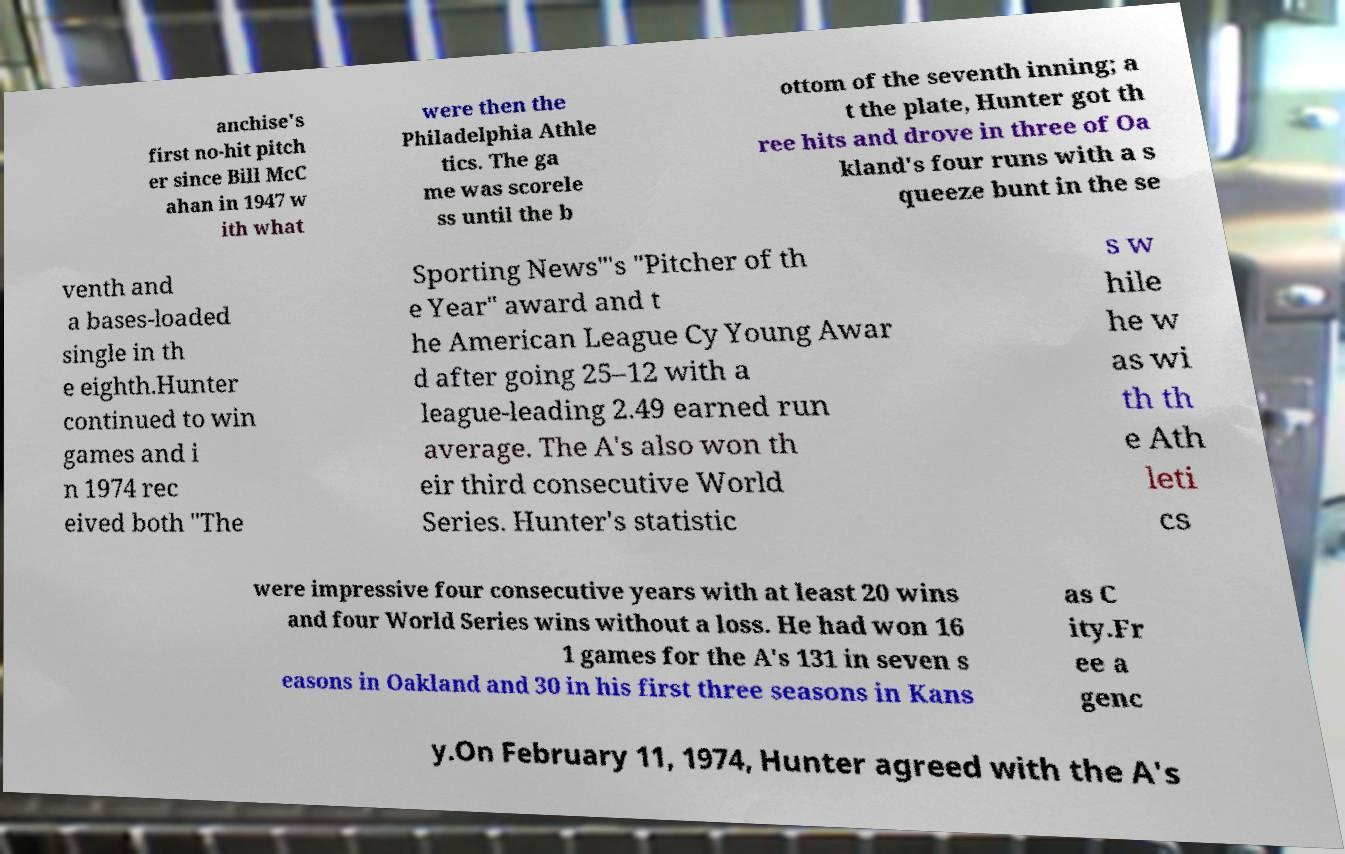Can you read and provide the text displayed in the image?This photo seems to have some interesting text. Can you extract and type it out for me? anchise's first no-hit pitch er since Bill McC ahan in 1947 w ith what were then the Philadelphia Athle tics. The ga me was scorele ss until the b ottom of the seventh inning; a t the plate, Hunter got th ree hits and drove in three of Oa kland's four runs with a s queeze bunt in the se venth and a bases-loaded single in th e eighth.Hunter continued to win games and i n 1974 rec eived both "The Sporting News"'s "Pitcher of th e Year" award and t he American League Cy Young Awar d after going 25–12 with a league-leading 2.49 earned run average. The A's also won th eir third consecutive World Series. Hunter's statistic s w hile he w as wi th th e Ath leti cs were impressive four consecutive years with at least 20 wins and four World Series wins without a loss. He had won 16 1 games for the A's 131 in seven s easons in Oakland and 30 in his first three seasons in Kans as C ity.Fr ee a genc y.On February 11, 1974, Hunter agreed with the A's 